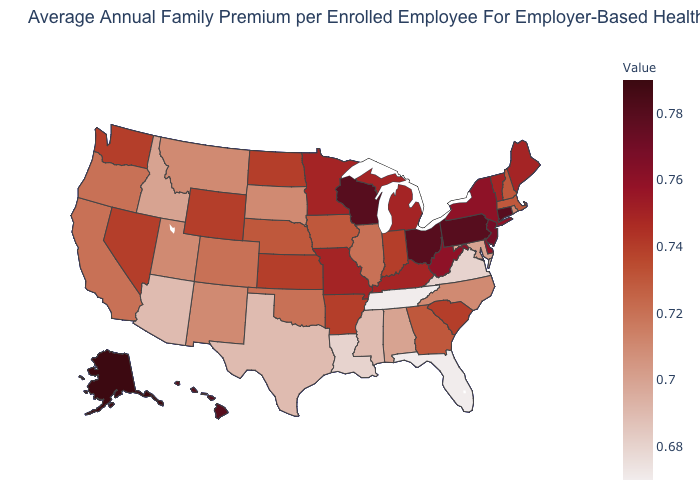Which states have the lowest value in the MidWest?
Short answer required. South Dakota. Which states have the lowest value in the USA?
Short answer required. Florida, Tennessee. Is the legend a continuous bar?
Quick response, please. Yes. Is the legend a continuous bar?
Quick response, please. Yes. Among the states that border Oregon , which have the lowest value?
Answer briefly. Idaho. Is the legend a continuous bar?
Keep it brief. Yes. Does West Virginia have the lowest value in the USA?
Be succinct. No. Does Pennsylvania have the highest value in the Northeast?
Give a very brief answer. Yes. Does Rhode Island have a higher value than Pennsylvania?
Quick response, please. No. 